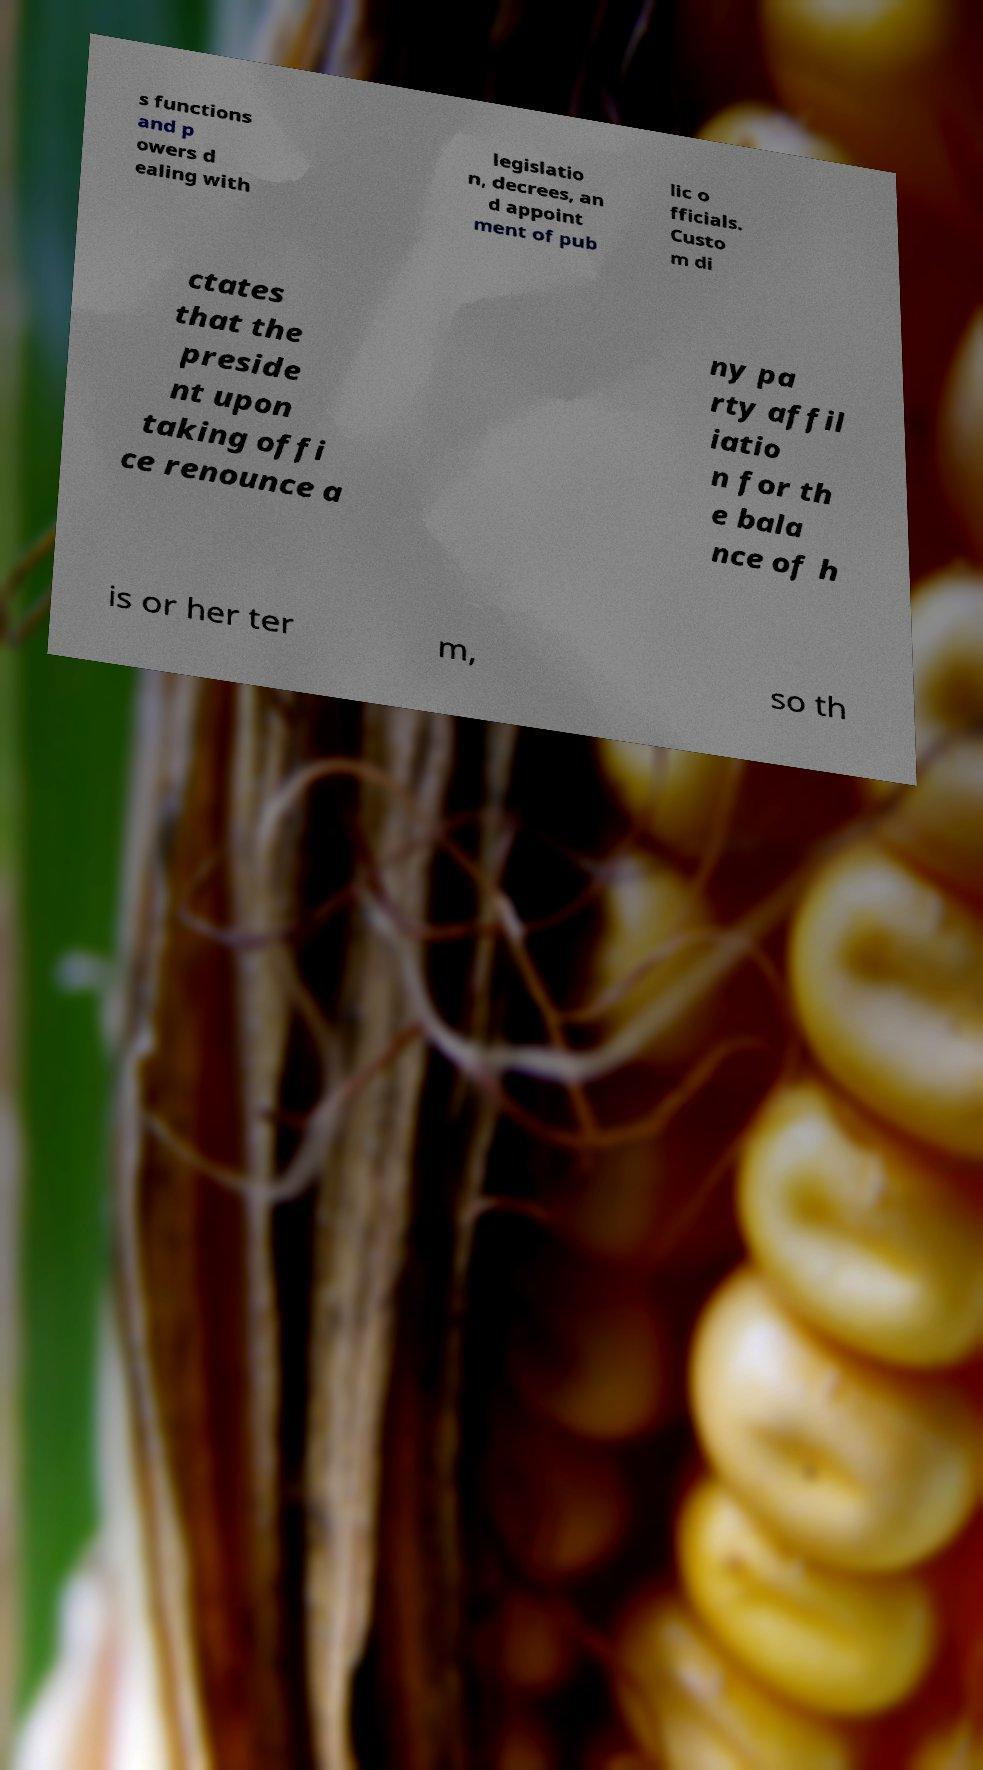There's text embedded in this image that I need extracted. Can you transcribe it verbatim? s functions and p owers d ealing with legislatio n, decrees, an d appoint ment of pub lic o fficials. Custo m di ctates that the preside nt upon taking offi ce renounce a ny pa rty affil iatio n for th e bala nce of h is or her ter m, so th 